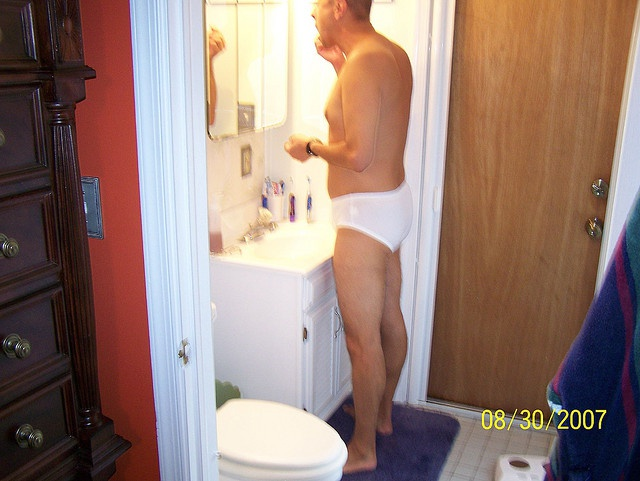Describe the objects in this image and their specific colors. I can see people in black, brown, tan, lightgray, and salmon tones, toilet in black, ivory, darkgray, and lightgray tones, sink in black, beige, and tan tones, toothbrush in black, brown, beige, violet, and lightpink tones, and toothbrush in black, tan, beige, darkgray, and gray tones in this image. 